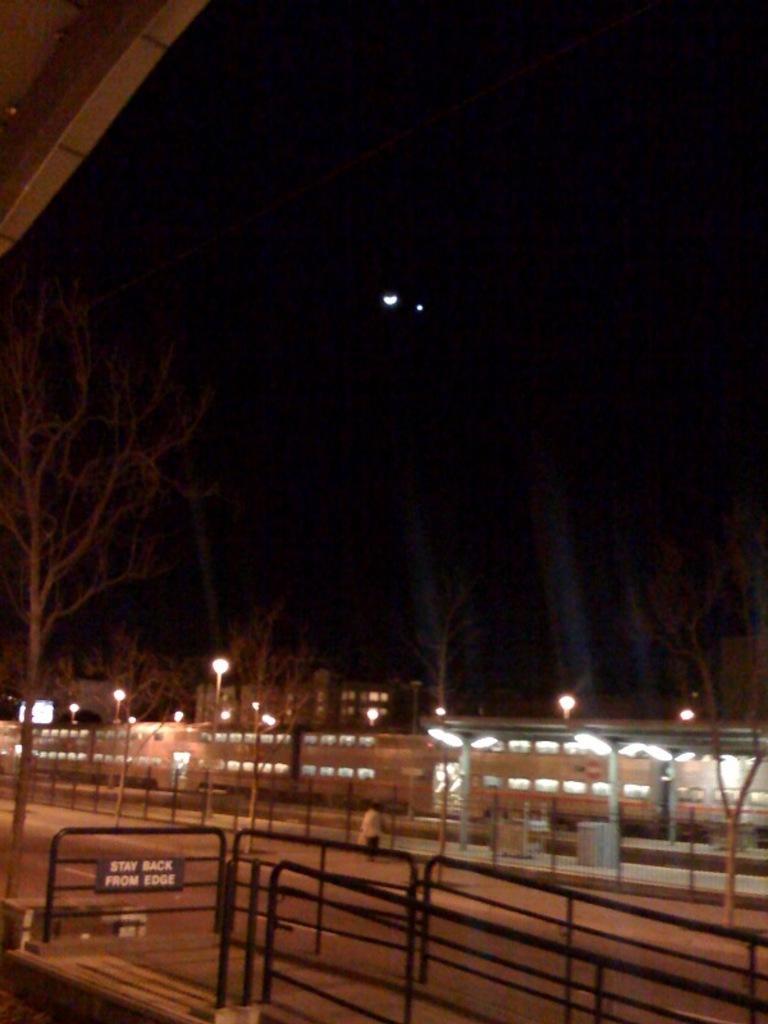Describe this image in one or two sentences. In this image I can see the railing. To the side I can see the person. In the back there are many lights and trees. And there is a black background. 